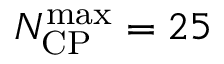Convert formula to latex. <formula><loc_0><loc_0><loc_500><loc_500>N _ { C P } ^ { \max } = 2 5</formula> 